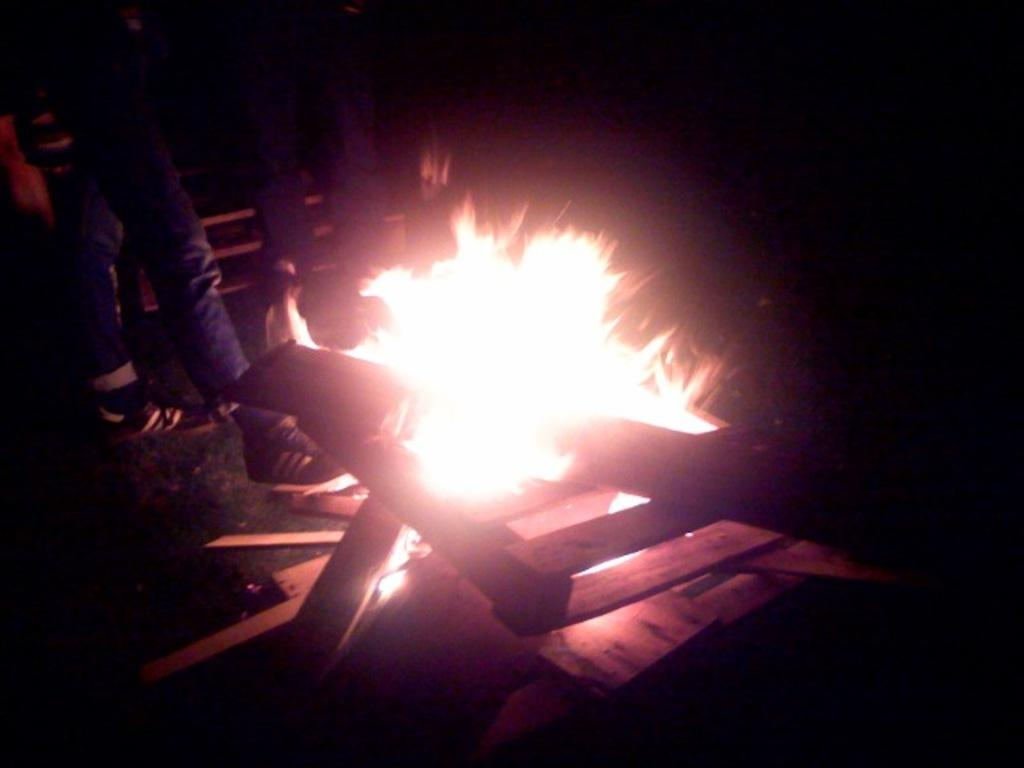What is the primary element in the image? There is fire in the image. What material is present in the image? There is wood in the image. Can you identify any human presence in the image? Yes, there are legs of people visible in the image. What is the surface on which the fire and wood are situated? The ground is visible in the image. What type of cakes are being served at the home in the image? A: There is no home or cakes present in the image; it features fire and wood with visible legs of people. Are there any plants visible in the image? There is no mention of plants in the provided facts, and therefore it cannot be determined if any are present in the image. 